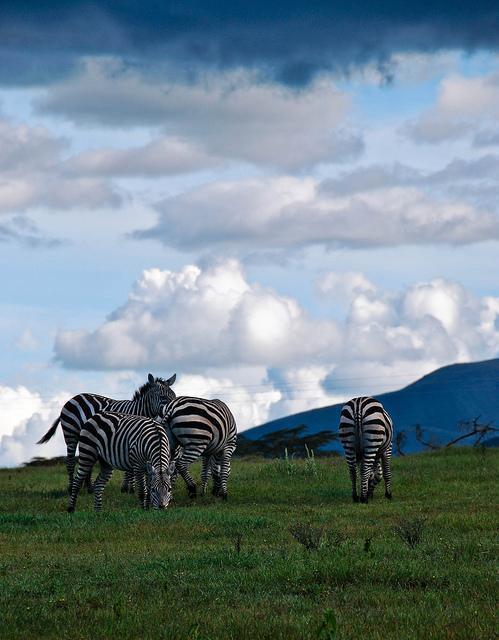How many zebras are grazing in the field before the mountain?
Select the correct answer and articulate reasoning with the following format: 'Answer: answer
Rationale: rationale.'
Options: Three, four, two, five. Answer: four.
Rationale: There are four of them. 